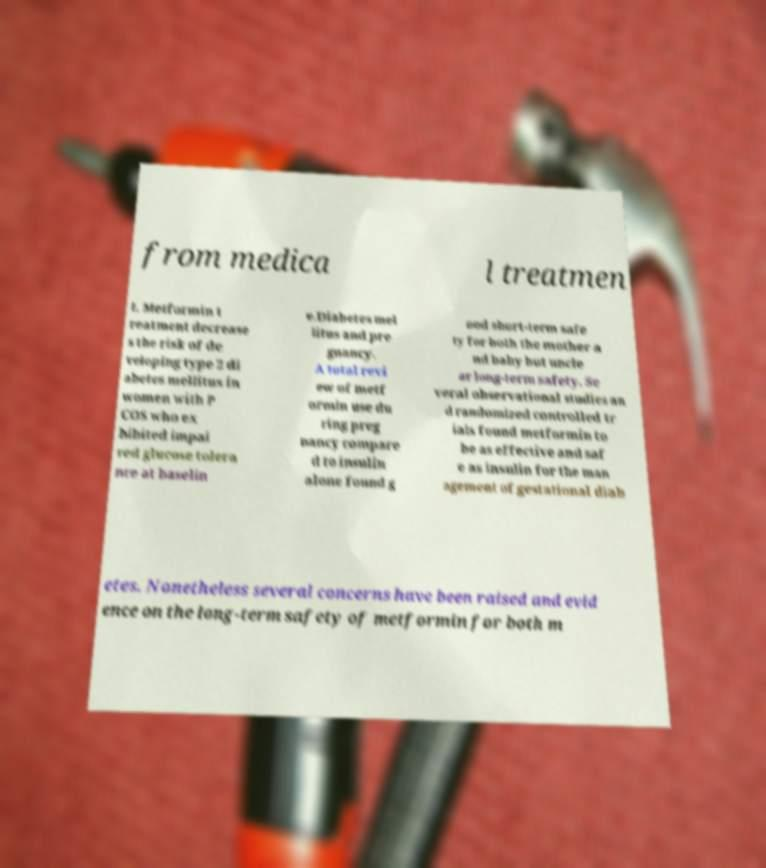Can you accurately transcribe the text from the provided image for me? from medica l treatmen t. Metformin t reatment decrease s the risk of de veloping type 2 di abetes mellitus in women with P COS who ex hibited impai red glucose tolera nce at baselin e.Diabetes mel litus and pre gnancy. A total revi ew of metf ormin use du ring preg nancy compare d to insulin alone found g ood short-term safe ty for both the mother a nd baby but uncle ar long-term safety. Se veral observational studies an d randomized controlled tr ials found metformin to be as effective and saf e as insulin for the man agement of gestational diab etes. Nonetheless several concerns have been raised and evid ence on the long-term safety of metformin for both m 